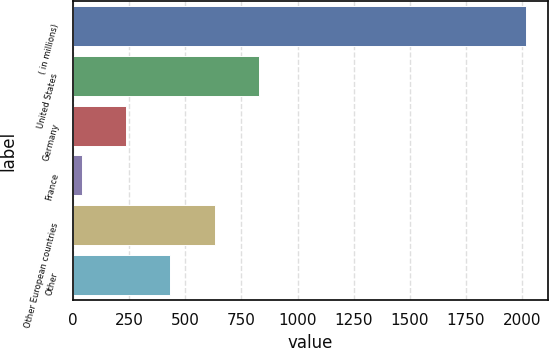Convert chart to OTSL. <chart><loc_0><loc_0><loc_500><loc_500><bar_chart><fcel>( in millions)<fcel>United States<fcel>Germany<fcel>France<fcel>Other European countries<fcel>Other<nl><fcel>2016<fcel>828.66<fcel>234.99<fcel>37.1<fcel>630.77<fcel>432.88<nl></chart> 